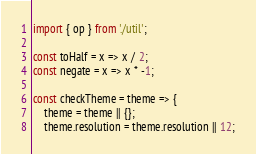<code> <loc_0><loc_0><loc_500><loc_500><_JavaScript_>import { op } from './util';

const toHalf = x => x / 2;
const negate = x => x * -1;

const checkTheme = theme => {
    theme = theme || {};
    theme.resolution = theme.resolution || 12;</code> 